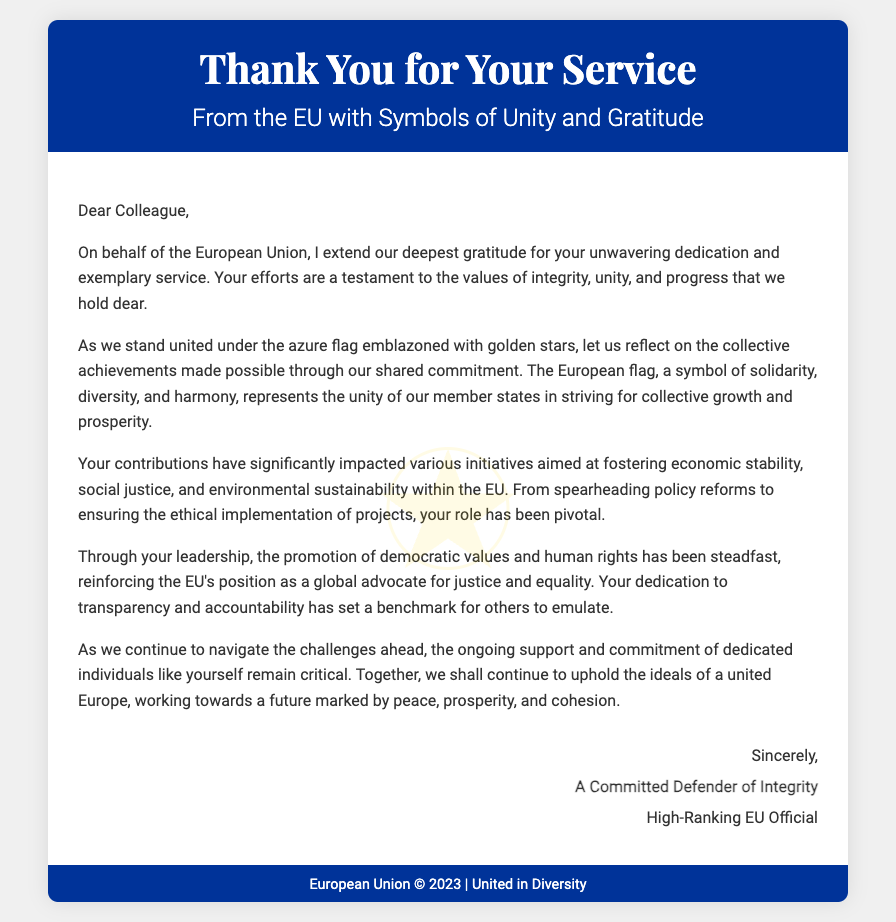What is the title of the card? The title is prominently displayed at the top of the card, indicating its purpose.
Answer: Thank You for Your Service Who is the card addressed to? The salutation at the beginning of the content indicates the recipient of the message.
Answer: Dear Colleague What does the EU flag symbolize according to the card? The document explains the meaning and significance of the EU flag within the context of unity.
Answer: Solidarity, diversity, and harmony What year is mentioned in the footnote? The footnote at the bottom provides the year related to the EU.
Answer: 2023 What is the closing phrase used in the signature? The final remarks before the signature give a formal closing to the message.
Answer: Sincerely What two key themes are highlighted regarding the receiver's contributions? The document addresses two major aspects of the receiver's impact through specific terms.
Answer: Economic stability, social justice Who authored the card? The signature section notes the identity of the individual who wrote the card.
Answer: A Committed Defender of Integrity What is emphasized as critical for future challenges? The content mentions a key element that is crucial as the EU moves forward.
Answer: Ongoing support and commitment 